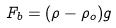<formula> <loc_0><loc_0><loc_500><loc_500>F _ { b } = ( \rho - \rho _ { o } ) g</formula> 